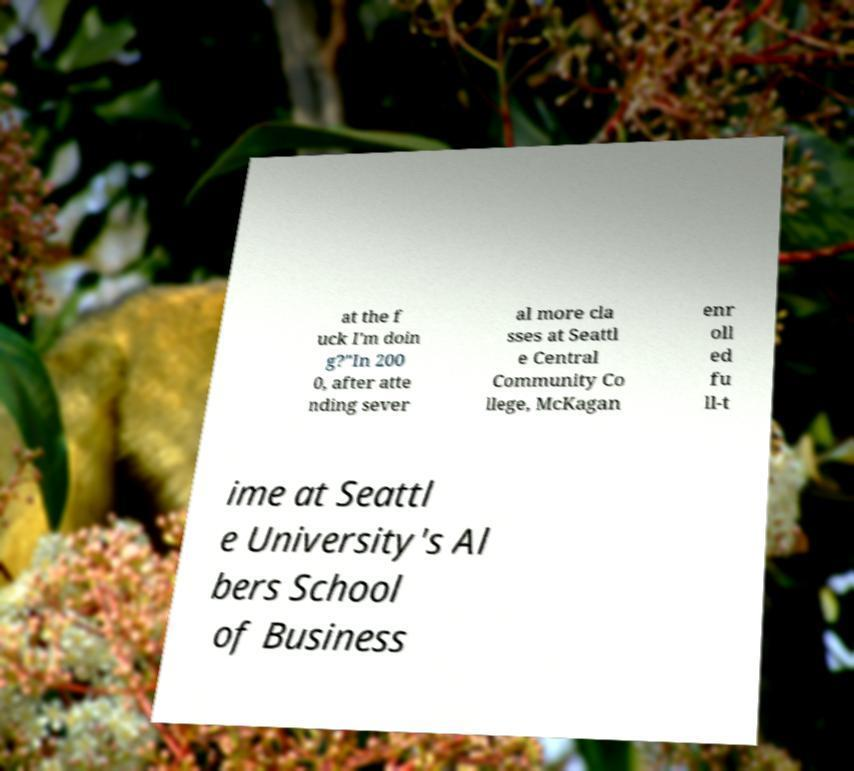Could you assist in decoding the text presented in this image and type it out clearly? at the f uck I'm doin g?"In 200 0, after atte nding sever al more cla sses at Seattl e Central Community Co llege, McKagan enr oll ed fu ll-t ime at Seattl e University's Al bers School of Business 